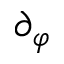Convert formula to latex. <formula><loc_0><loc_0><loc_500><loc_500>\partial _ { \varphi }</formula> 